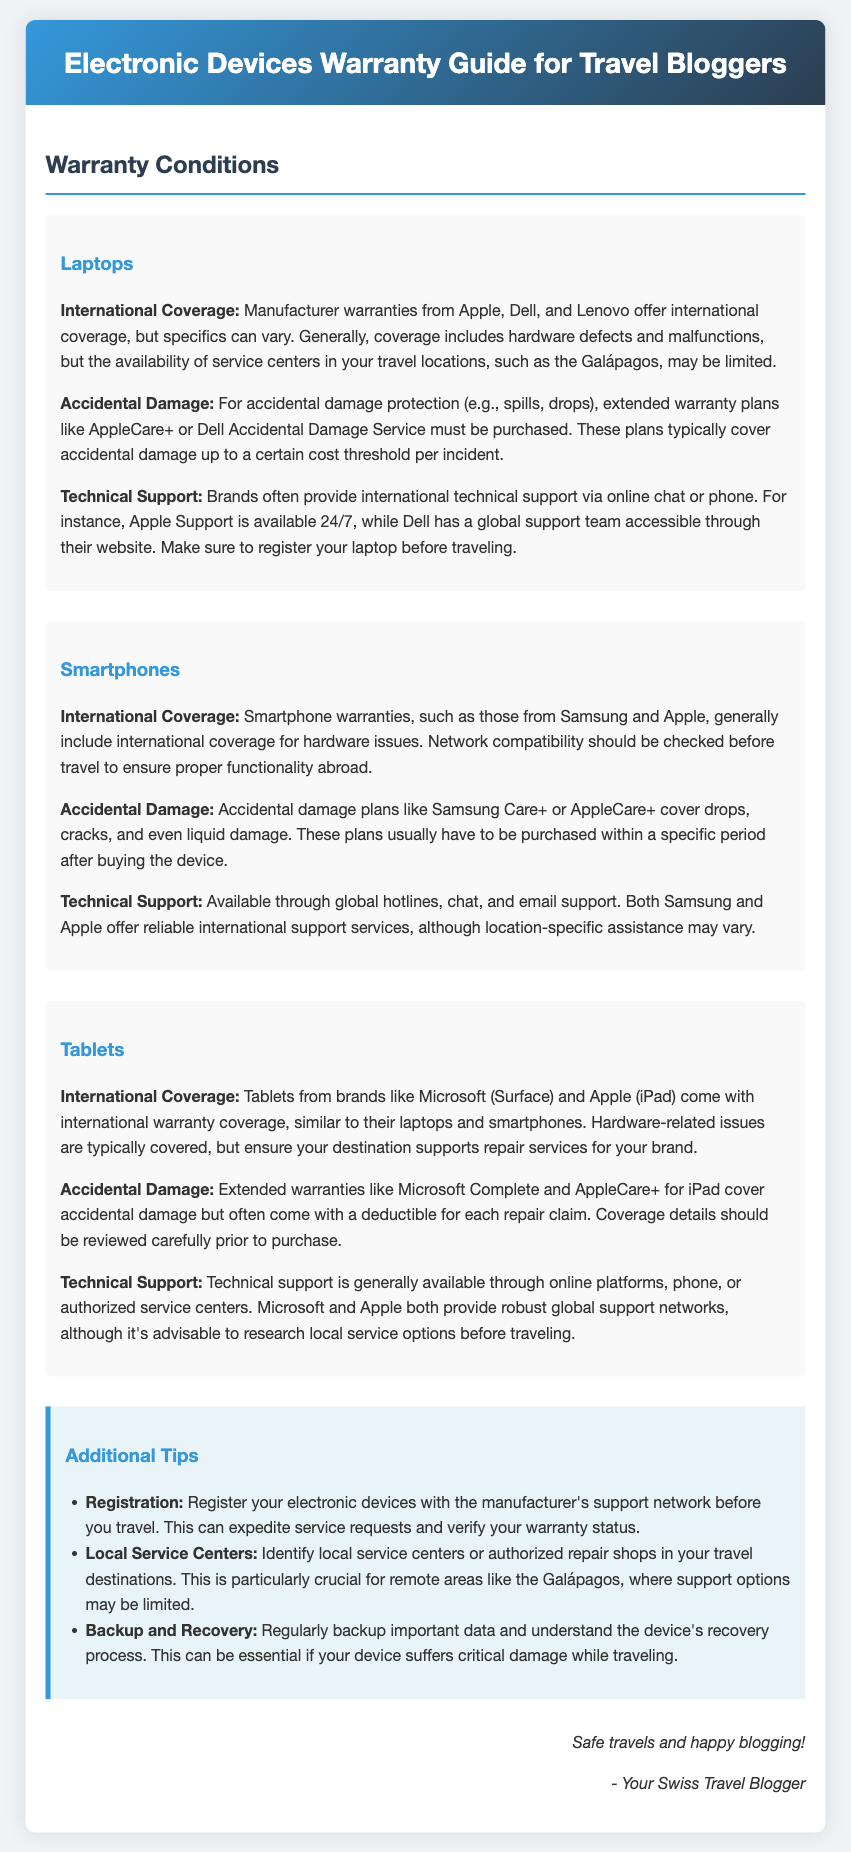What type of coverage do laptops generally have? Laptops typically have international coverage that includes hardware defects and malfunctions, but the availability of service centers may be limited in travel locations.
Answer: International coverage What does AppleCare+ cover for laptops? AppleCare+ covers accidental damage protection for laptops, typically up to a certain cost threshold per incident.
Answer: Accidental damage Which brands offer international technical support for laptops? Brands like Apple and Dell provide international technical support via online chat or phone.
Answer: Apple and Dell What is the coverage for accidental damage on smartphones? Accidental damage plans like Samsung Care+ or AppleCare+ cover drops, cracks, and even liquid damage.
Answer: Drops, cracks, and liquid damage Which brand's tablet includes international warranty coverage? Tablets from brands like Microsoft and Apple come with international warranty coverage.
Answer: Microsoft and Apple Why is it important to register devices before traveling? Registering devices can expedite service requests and verify warranty status.
Answer: Expedite service requests What should you identify before traveling to remote areas? You should identify local service centers or authorized repair shops in your travel destinations.
Answer: Local service centers How can travel bloggers protect their important data? Travel bloggers should regularly back up important data and understand the device's recovery process.
Answer: Back up important data What does the warranty guide emphasize for devices in the Galápagos? The guide emphasizes that support options may be limited in remote areas like the Galápagos.
Answer: Limited support options 